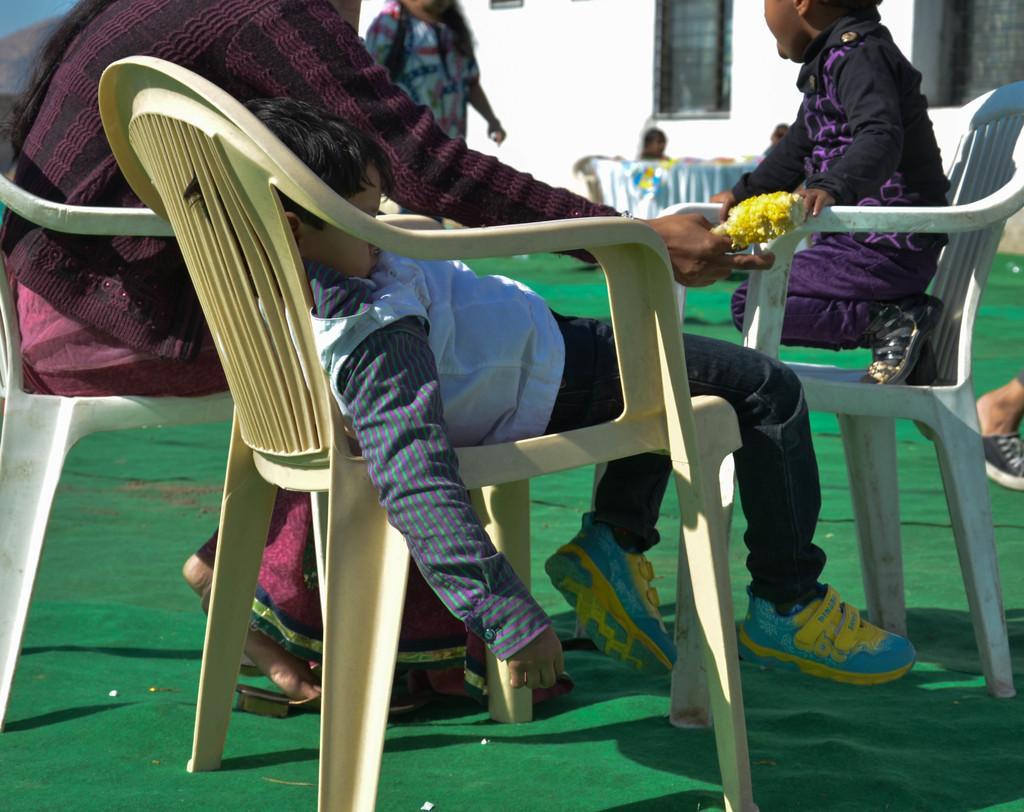Please provide a concise description of this image. This is a picture taken in the outdoors. There are three persons sitting on chairs. In front of the people there is a person standing on a floor and the floor is covered with a green mat. behind the people there is a wall and glass windows. 